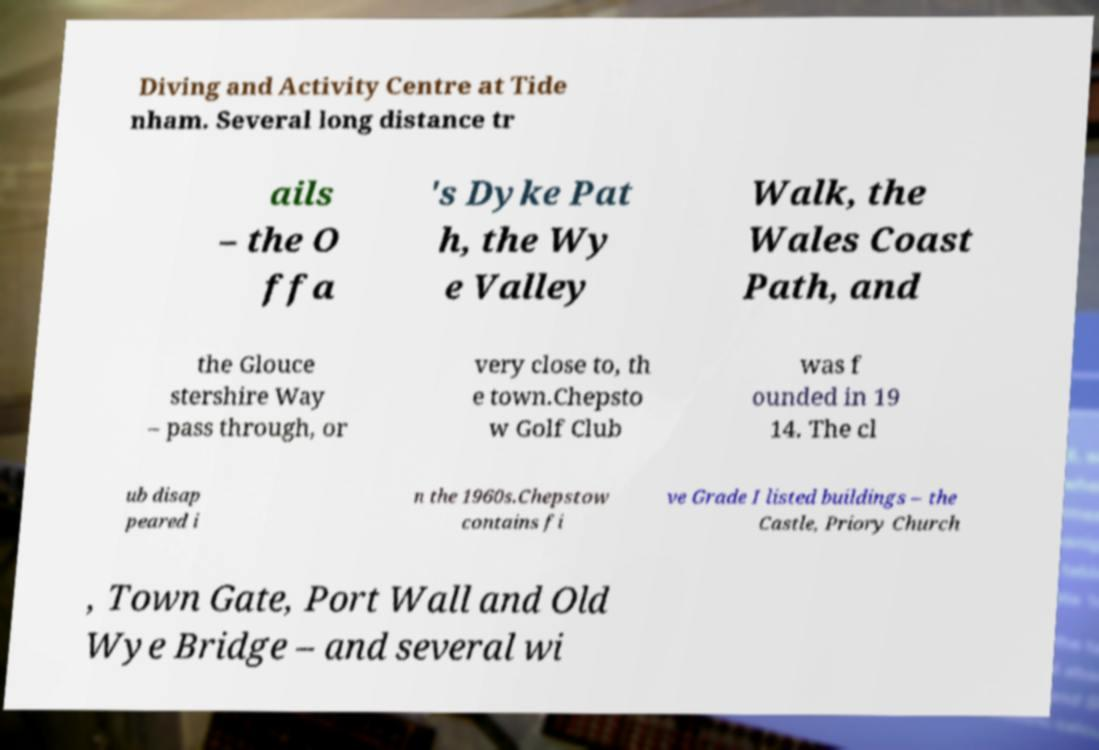I need the written content from this picture converted into text. Can you do that? Diving and Activity Centre at Tide nham. Several long distance tr ails – the O ffa 's Dyke Pat h, the Wy e Valley Walk, the Wales Coast Path, and the Glouce stershire Way – pass through, or very close to, th e town.Chepsto w Golf Club was f ounded in 19 14. The cl ub disap peared i n the 1960s.Chepstow contains fi ve Grade I listed buildings – the Castle, Priory Church , Town Gate, Port Wall and Old Wye Bridge – and several wi 